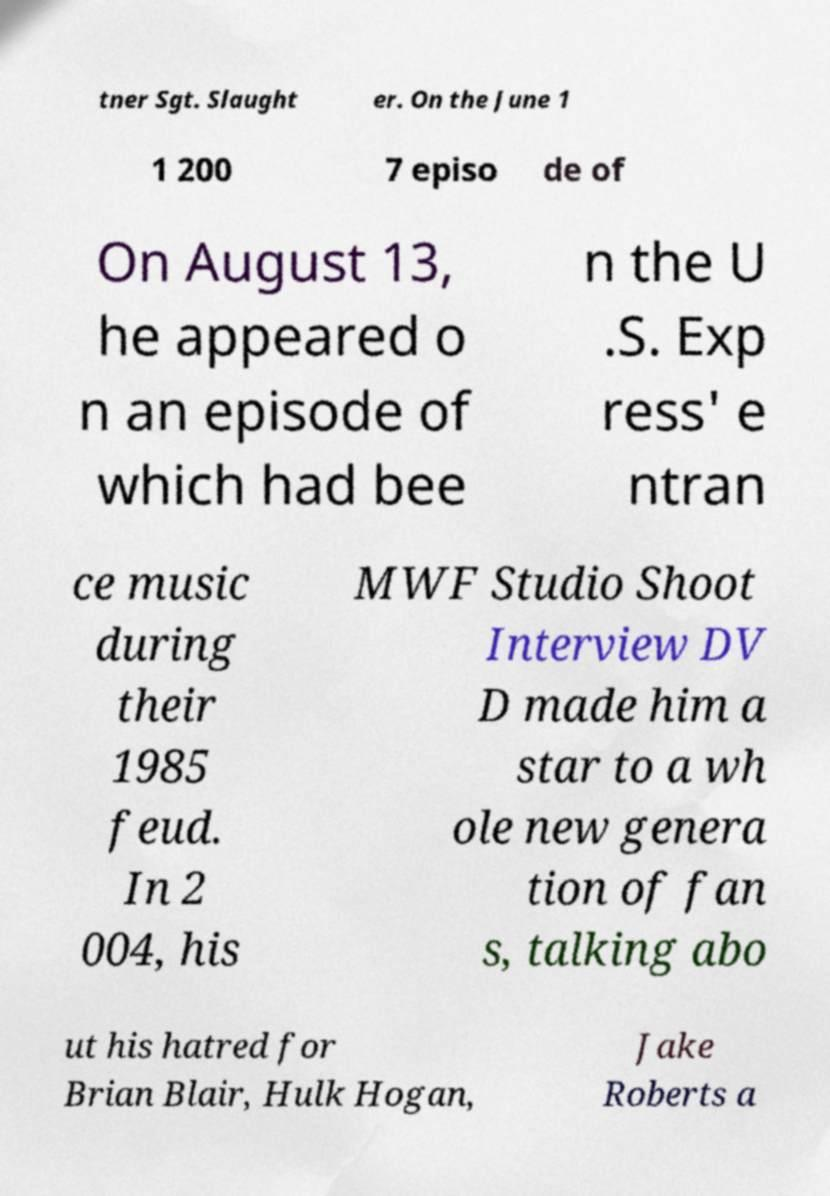Can you accurately transcribe the text from the provided image for me? tner Sgt. Slaught er. On the June 1 1 200 7 episo de of On August 13, he appeared o n an episode of which had bee n the U .S. Exp ress' e ntran ce music during their 1985 feud. In 2 004, his MWF Studio Shoot Interview DV D made him a star to a wh ole new genera tion of fan s, talking abo ut his hatred for Brian Blair, Hulk Hogan, Jake Roberts a 